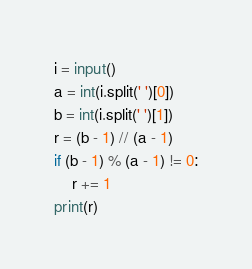<code> <loc_0><loc_0><loc_500><loc_500><_Python_>i = input()
a = int(i.split(' ')[0])
b = int(i.split(' ')[1])
r = (b - 1) // (a - 1)
if (b - 1) % (a - 1) != 0:
    r += 1
print(r)
</code> 